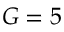<formula> <loc_0><loc_0><loc_500><loc_500>G = 5</formula> 